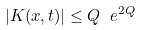<formula> <loc_0><loc_0><loc_500><loc_500>| K ( x , t ) | \leq Q \ e ^ { 2 Q }</formula> 